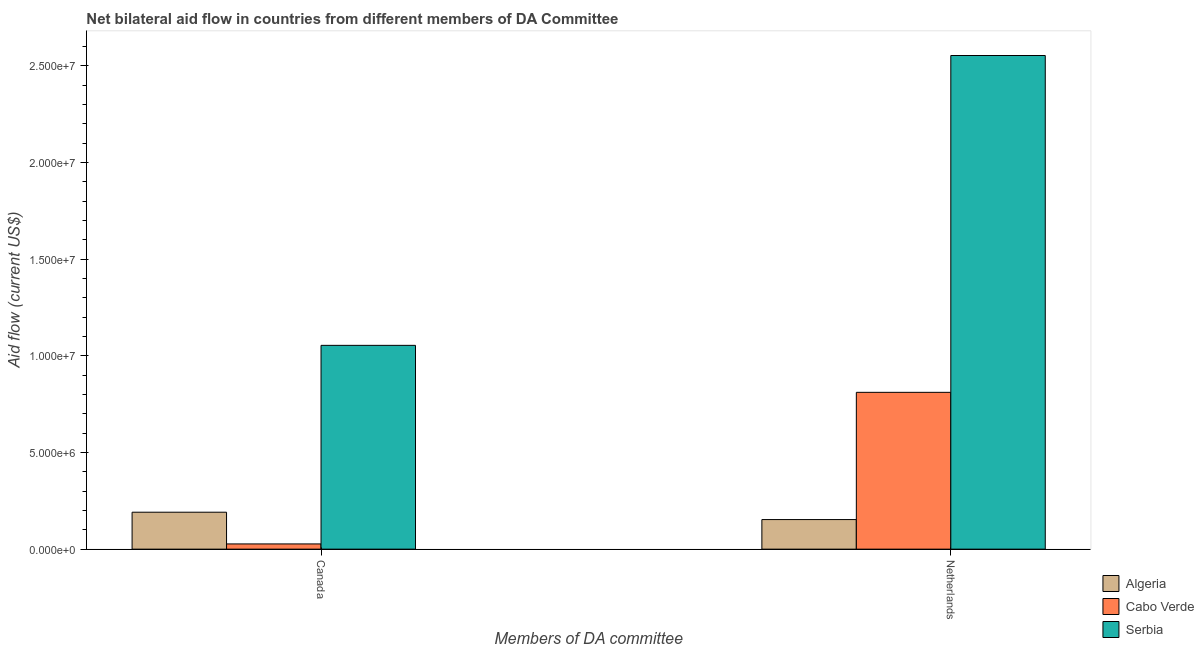Are the number of bars per tick equal to the number of legend labels?
Ensure brevity in your answer.  Yes. What is the amount of aid given by canada in Serbia?
Keep it short and to the point. 1.05e+07. Across all countries, what is the maximum amount of aid given by netherlands?
Your response must be concise. 2.55e+07. Across all countries, what is the minimum amount of aid given by canada?
Your response must be concise. 2.70e+05. In which country was the amount of aid given by canada maximum?
Keep it short and to the point. Serbia. In which country was the amount of aid given by canada minimum?
Offer a very short reply. Cabo Verde. What is the total amount of aid given by netherlands in the graph?
Make the answer very short. 3.52e+07. What is the difference between the amount of aid given by canada in Cabo Verde and that in Serbia?
Make the answer very short. -1.03e+07. What is the difference between the amount of aid given by netherlands in Serbia and the amount of aid given by canada in Cabo Verde?
Your response must be concise. 2.53e+07. What is the average amount of aid given by canada per country?
Make the answer very short. 4.24e+06. What is the difference between the amount of aid given by canada and amount of aid given by netherlands in Cabo Verde?
Keep it short and to the point. -7.84e+06. What is the ratio of the amount of aid given by netherlands in Algeria to that in Cabo Verde?
Keep it short and to the point. 0.19. Is the amount of aid given by canada in Cabo Verde less than that in Algeria?
Keep it short and to the point. Yes. What does the 2nd bar from the left in Netherlands represents?
Ensure brevity in your answer.  Cabo Verde. What does the 1st bar from the right in Netherlands represents?
Your answer should be very brief. Serbia. How many bars are there?
Keep it short and to the point. 6. What is the difference between two consecutive major ticks on the Y-axis?
Make the answer very short. 5.00e+06. Are the values on the major ticks of Y-axis written in scientific E-notation?
Your answer should be compact. Yes. Does the graph contain grids?
Your answer should be compact. No. How many legend labels are there?
Your answer should be compact. 3. What is the title of the graph?
Your answer should be very brief. Net bilateral aid flow in countries from different members of DA Committee. Does "High income" appear as one of the legend labels in the graph?
Make the answer very short. No. What is the label or title of the X-axis?
Keep it short and to the point. Members of DA committee. What is the label or title of the Y-axis?
Ensure brevity in your answer.  Aid flow (current US$). What is the Aid flow (current US$) of Algeria in Canada?
Ensure brevity in your answer.  1.91e+06. What is the Aid flow (current US$) of Serbia in Canada?
Ensure brevity in your answer.  1.05e+07. What is the Aid flow (current US$) of Algeria in Netherlands?
Keep it short and to the point. 1.53e+06. What is the Aid flow (current US$) of Cabo Verde in Netherlands?
Your answer should be very brief. 8.11e+06. What is the Aid flow (current US$) of Serbia in Netherlands?
Your answer should be compact. 2.55e+07. Across all Members of DA committee, what is the maximum Aid flow (current US$) of Algeria?
Provide a succinct answer. 1.91e+06. Across all Members of DA committee, what is the maximum Aid flow (current US$) of Cabo Verde?
Keep it short and to the point. 8.11e+06. Across all Members of DA committee, what is the maximum Aid flow (current US$) of Serbia?
Ensure brevity in your answer.  2.55e+07. Across all Members of DA committee, what is the minimum Aid flow (current US$) of Algeria?
Provide a succinct answer. 1.53e+06. Across all Members of DA committee, what is the minimum Aid flow (current US$) of Serbia?
Your response must be concise. 1.05e+07. What is the total Aid flow (current US$) of Algeria in the graph?
Your answer should be very brief. 3.44e+06. What is the total Aid flow (current US$) in Cabo Verde in the graph?
Provide a short and direct response. 8.38e+06. What is the total Aid flow (current US$) in Serbia in the graph?
Your response must be concise. 3.61e+07. What is the difference between the Aid flow (current US$) in Cabo Verde in Canada and that in Netherlands?
Provide a succinct answer. -7.84e+06. What is the difference between the Aid flow (current US$) of Serbia in Canada and that in Netherlands?
Your answer should be compact. -1.50e+07. What is the difference between the Aid flow (current US$) in Algeria in Canada and the Aid flow (current US$) in Cabo Verde in Netherlands?
Your answer should be compact. -6.20e+06. What is the difference between the Aid flow (current US$) of Algeria in Canada and the Aid flow (current US$) of Serbia in Netherlands?
Make the answer very short. -2.36e+07. What is the difference between the Aid flow (current US$) of Cabo Verde in Canada and the Aid flow (current US$) of Serbia in Netherlands?
Your answer should be very brief. -2.53e+07. What is the average Aid flow (current US$) in Algeria per Members of DA committee?
Give a very brief answer. 1.72e+06. What is the average Aid flow (current US$) of Cabo Verde per Members of DA committee?
Your answer should be compact. 4.19e+06. What is the average Aid flow (current US$) in Serbia per Members of DA committee?
Make the answer very short. 1.80e+07. What is the difference between the Aid flow (current US$) of Algeria and Aid flow (current US$) of Cabo Verde in Canada?
Provide a short and direct response. 1.64e+06. What is the difference between the Aid flow (current US$) in Algeria and Aid flow (current US$) in Serbia in Canada?
Offer a terse response. -8.63e+06. What is the difference between the Aid flow (current US$) of Cabo Verde and Aid flow (current US$) of Serbia in Canada?
Your answer should be compact. -1.03e+07. What is the difference between the Aid flow (current US$) of Algeria and Aid flow (current US$) of Cabo Verde in Netherlands?
Your response must be concise. -6.58e+06. What is the difference between the Aid flow (current US$) of Algeria and Aid flow (current US$) of Serbia in Netherlands?
Offer a very short reply. -2.40e+07. What is the difference between the Aid flow (current US$) in Cabo Verde and Aid flow (current US$) in Serbia in Netherlands?
Your response must be concise. -1.74e+07. What is the ratio of the Aid flow (current US$) of Algeria in Canada to that in Netherlands?
Provide a short and direct response. 1.25. What is the ratio of the Aid flow (current US$) in Serbia in Canada to that in Netherlands?
Offer a terse response. 0.41. What is the difference between the highest and the second highest Aid flow (current US$) of Cabo Verde?
Keep it short and to the point. 7.84e+06. What is the difference between the highest and the second highest Aid flow (current US$) of Serbia?
Keep it short and to the point. 1.50e+07. What is the difference between the highest and the lowest Aid flow (current US$) in Cabo Verde?
Your answer should be compact. 7.84e+06. What is the difference between the highest and the lowest Aid flow (current US$) of Serbia?
Your answer should be compact. 1.50e+07. 